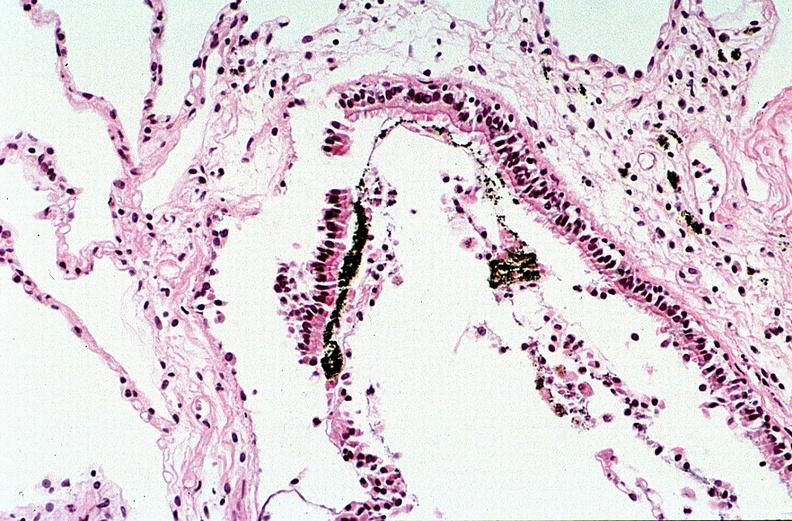where is this?
Answer the question using a single word or phrase. Lung 